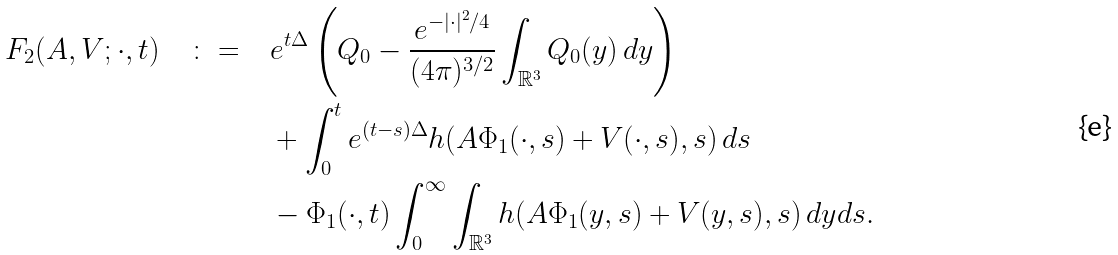<formula> <loc_0><loc_0><loc_500><loc_500>F _ { 2 } ( A , V ; \cdot , t ) \quad \colon = & \quad e ^ { t \Delta } \left ( Q _ { 0 } - \frac { e ^ { - | \cdot | ^ { 2 } / 4 } } { ( 4 \pi ) ^ { 3 / 2 } } \int _ { \mathbb { R } ^ { 3 } } Q _ { 0 } ( y ) \, d y \right ) \\ & \quad + \int _ { 0 } ^ { t } e ^ { ( t - s ) \Delta } h ( A \Phi _ { 1 } ( \cdot , s ) + V ( \cdot , s ) , s ) \, d s \\ & \quad - \Phi _ { 1 } ( \cdot , t ) \int _ { 0 } ^ { \infty } \int _ { \mathbb { R } ^ { 3 } } h ( A \Phi _ { 1 } ( y , s ) + V ( y , s ) , s ) \, d y d s .</formula> 